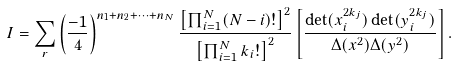<formula> <loc_0><loc_0><loc_500><loc_500>I = \sum _ { r } \left ( \frac { - 1 } { 4 } \right ) ^ { n _ { 1 } + n _ { 2 } + \cdots + n _ { N } } \frac { \left [ \prod _ { i = 1 } ^ { N } ( N - i ) ! \right ] ^ { 2 } } { \left [ \prod _ { i = 1 } ^ { N } k _ { i } ! \right ] ^ { 2 } } \left [ \frac { \det ( x _ { i } ^ { 2 k _ { j } } ) \det ( y _ { i } ^ { 2 k _ { j } } ) } { \Delta ( x ^ { 2 } ) \Delta ( y ^ { 2 } ) } \right ] .</formula> 